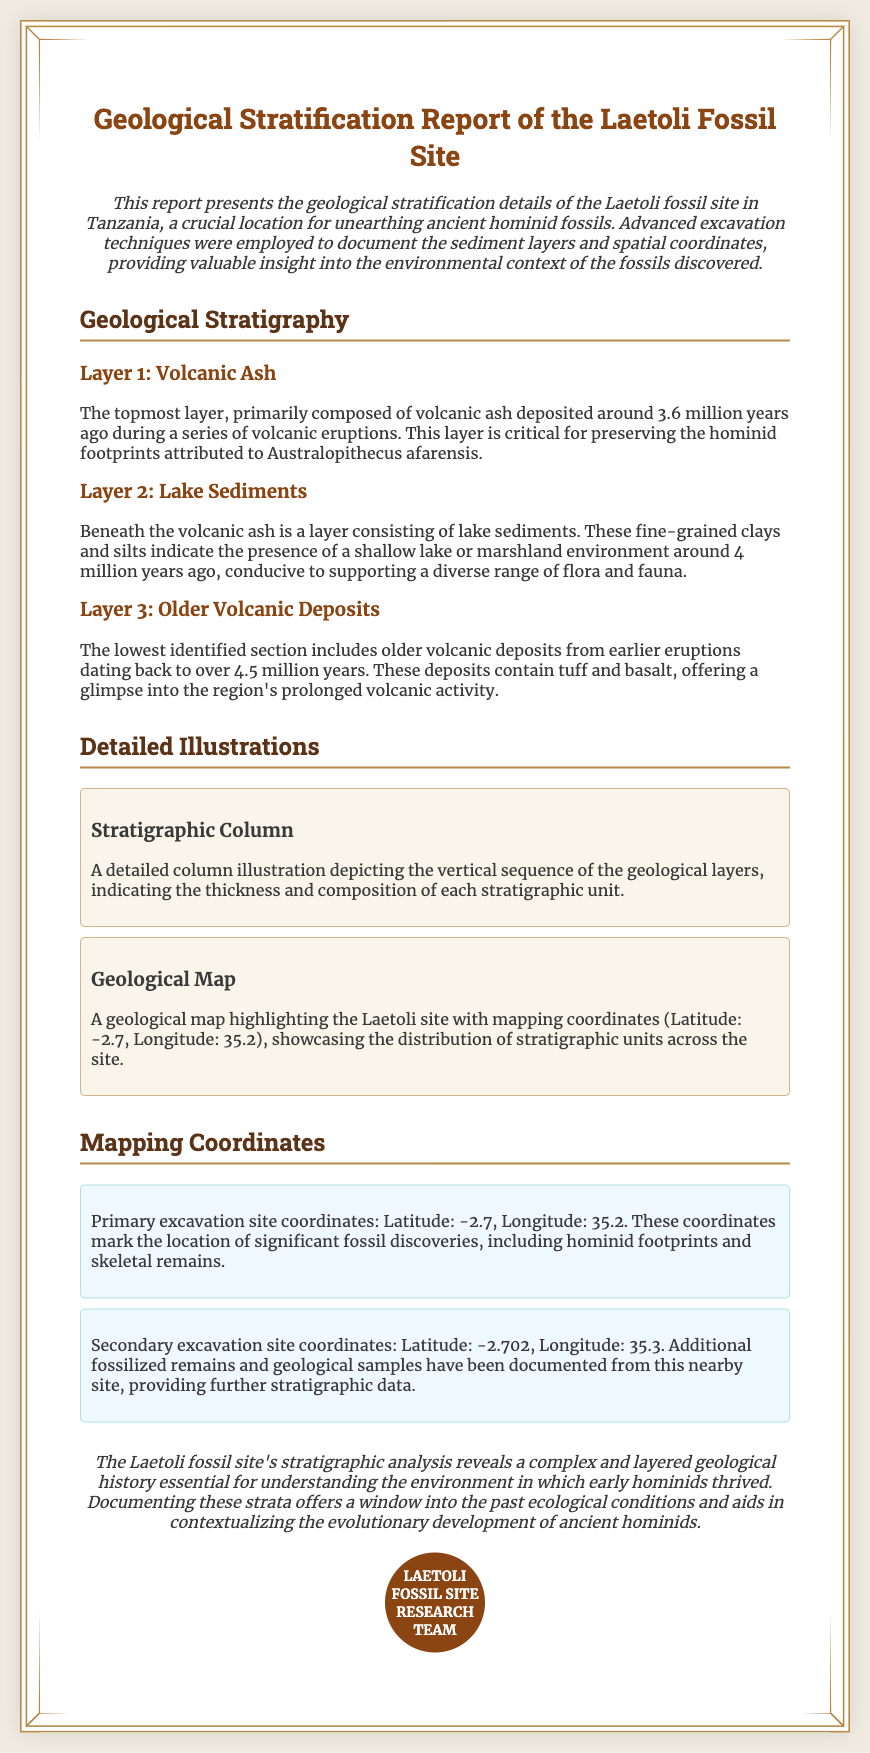What is the title of the report? The title of the report is prominently displayed at the top of the document.
Answer: Geological Stratification Report of the Laetoli Fossil Site How many distinct geological layers are described? The document provides detailed information about three geological layers identified at the site.
Answer: Three What type of sediments compose Layer 2? The specific type of sediment making up Layer 2 is detailed in the stratigraphy section of the report.
Answer: Lake Sediments What are the coordinates of the primary excavation site? The coordinates for the primary excavation site are clearly stated within the mapping coordinates section.
Answer: Latitude: -2.7, Longitude: 35.2 How old is the volcanic ash layer? The age of this layer is mentioned in the description, providing essential context for its significance.
Answer: 3.6 million years What significant discoveries were made at the primary excavation site? The document lists the major fossils found during excavation to highlight the importance of the site.
Answer: Hominid footprints and skeletal remains What ecological conditions are inferred from the geological analysis? The document suggests specific ecological insights based on the layering and composition of sediments.
Answer: Past ecological conditions Which illustration depicts the vertical sequence of geological layers? The detailed illustration is explicitly referred to in the section discussing visuals.
Answer: Stratigraphic Column 